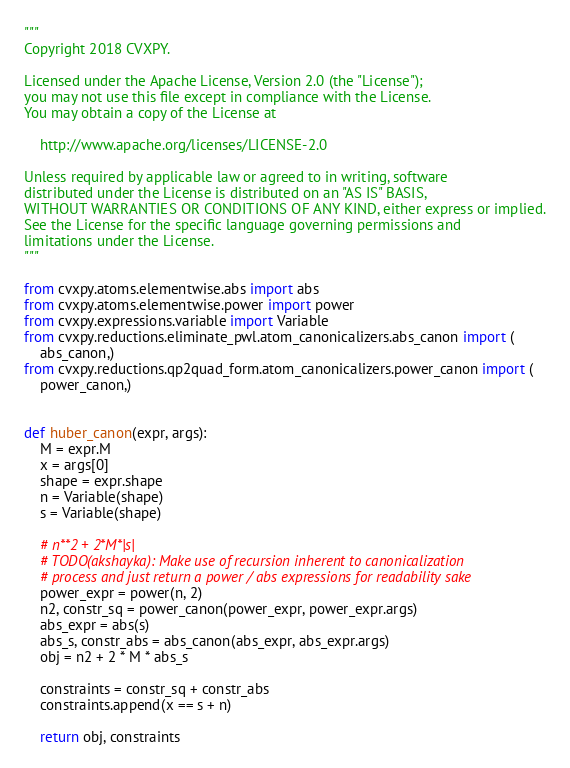<code> <loc_0><loc_0><loc_500><loc_500><_Python_>"""
Copyright 2018 CVXPY.

Licensed under the Apache License, Version 2.0 (the "License");
you may not use this file except in compliance with the License.
You may obtain a copy of the License at

    http://www.apache.org/licenses/LICENSE-2.0

Unless required by applicable law or agreed to in writing, software
distributed under the License is distributed on an "AS IS" BASIS,
WITHOUT WARRANTIES OR CONDITIONS OF ANY KIND, either express or implied.
See the License for the specific language governing permissions and
limitations under the License.
"""

from cvxpy.atoms.elementwise.abs import abs
from cvxpy.atoms.elementwise.power import power
from cvxpy.expressions.variable import Variable
from cvxpy.reductions.eliminate_pwl.atom_canonicalizers.abs_canon import (
    abs_canon,)
from cvxpy.reductions.qp2quad_form.atom_canonicalizers.power_canon import (
    power_canon,)


def huber_canon(expr, args):
    M = expr.M
    x = args[0]
    shape = expr.shape
    n = Variable(shape)
    s = Variable(shape)

    # n**2 + 2*M*|s|
    # TODO(akshayka): Make use of recursion inherent to canonicalization
    # process and just return a power / abs expressions for readability sake
    power_expr = power(n, 2)
    n2, constr_sq = power_canon(power_expr, power_expr.args)
    abs_expr = abs(s)
    abs_s, constr_abs = abs_canon(abs_expr, abs_expr.args)
    obj = n2 + 2 * M * abs_s

    constraints = constr_sq + constr_abs
    constraints.append(x == s + n)

    return obj, constraints
</code> 